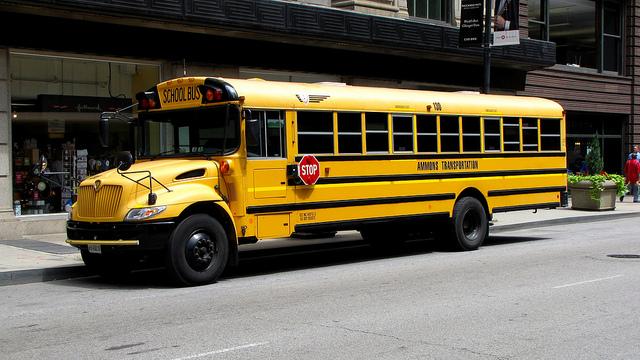Is this bus moving?
Answer briefly. No. Who owns this bus?
Give a very brief answer. School. What is written on the red sign on the side of the bus?
Concise answer only. Stop. What type of bus is this?
Short answer required. School. What is directly behind the back of the bus?
Quick response, please. Plant. 